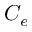<formula> <loc_0><loc_0><loc_500><loc_500>C _ { e }</formula> 